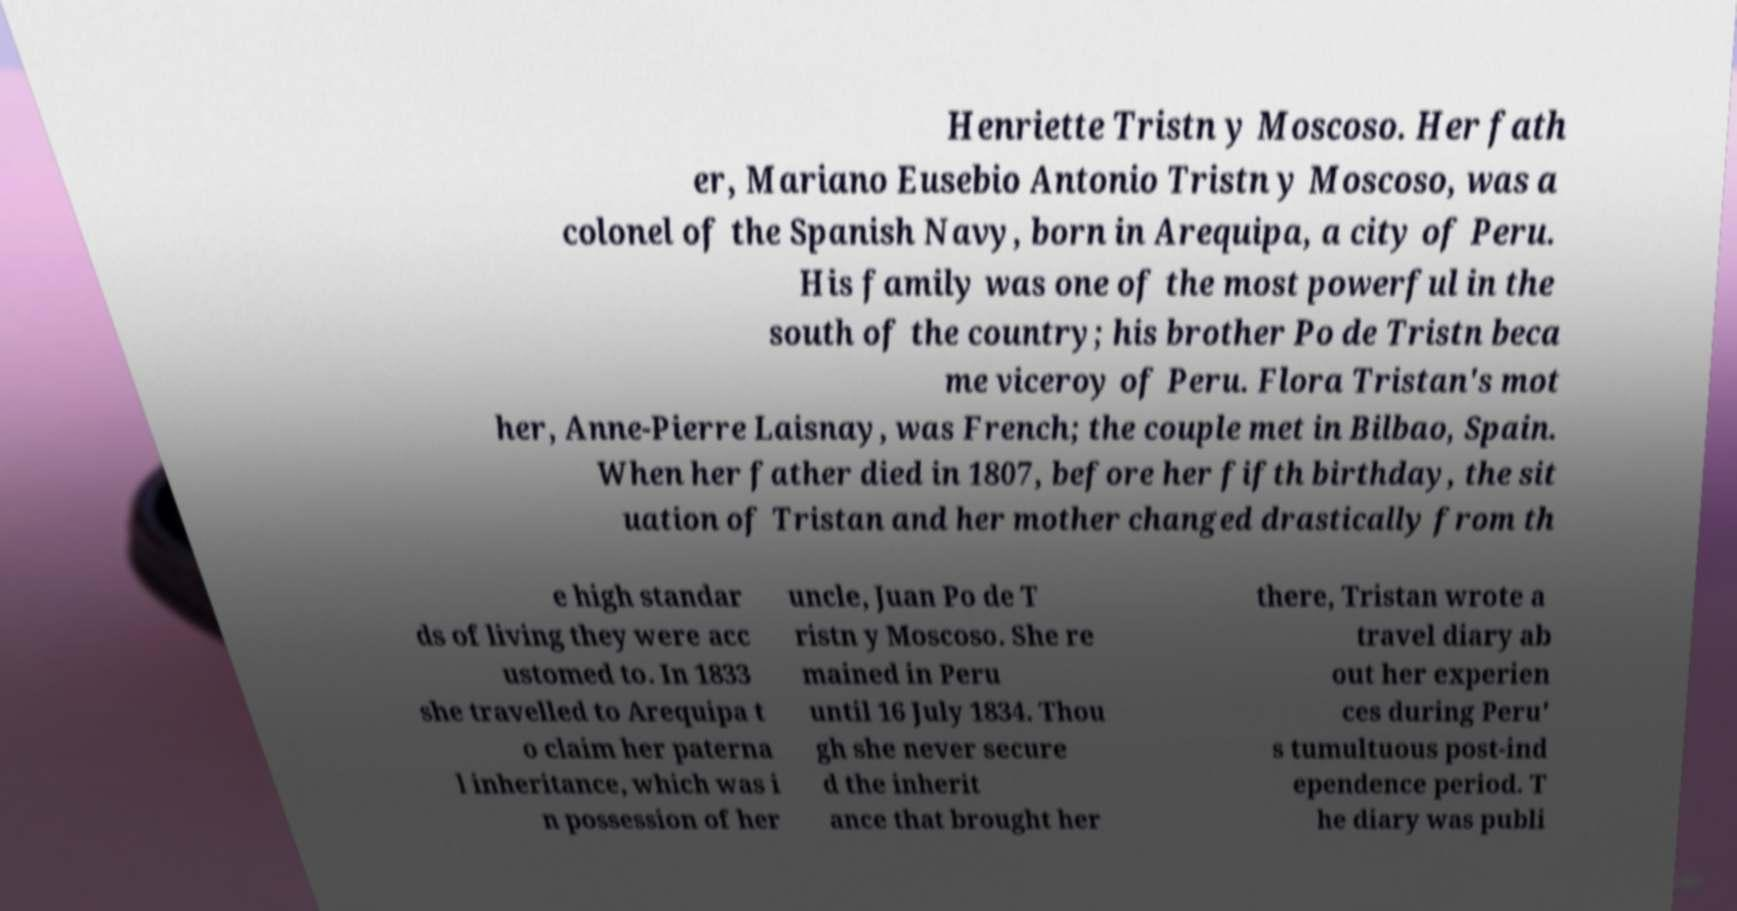Could you extract and type out the text from this image? Henriette Tristn y Moscoso. Her fath er, Mariano Eusebio Antonio Tristn y Moscoso, was a colonel of the Spanish Navy, born in Arequipa, a city of Peru. His family was one of the most powerful in the south of the country; his brother Po de Tristn beca me viceroy of Peru. Flora Tristan's mot her, Anne-Pierre Laisnay, was French; the couple met in Bilbao, Spain. When her father died in 1807, before her fifth birthday, the sit uation of Tristan and her mother changed drastically from th e high standar ds of living they were acc ustomed to. In 1833 she travelled to Arequipa t o claim her paterna l inheritance, which was i n possession of her uncle, Juan Po de T ristn y Moscoso. She re mained in Peru until 16 July 1834. Thou gh she never secure d the inherit ance that brought her there, Tristan wrote a travel diary ab out her experien ces during Peru' s tumultuous post-ind ependence period. T he diary was publi 